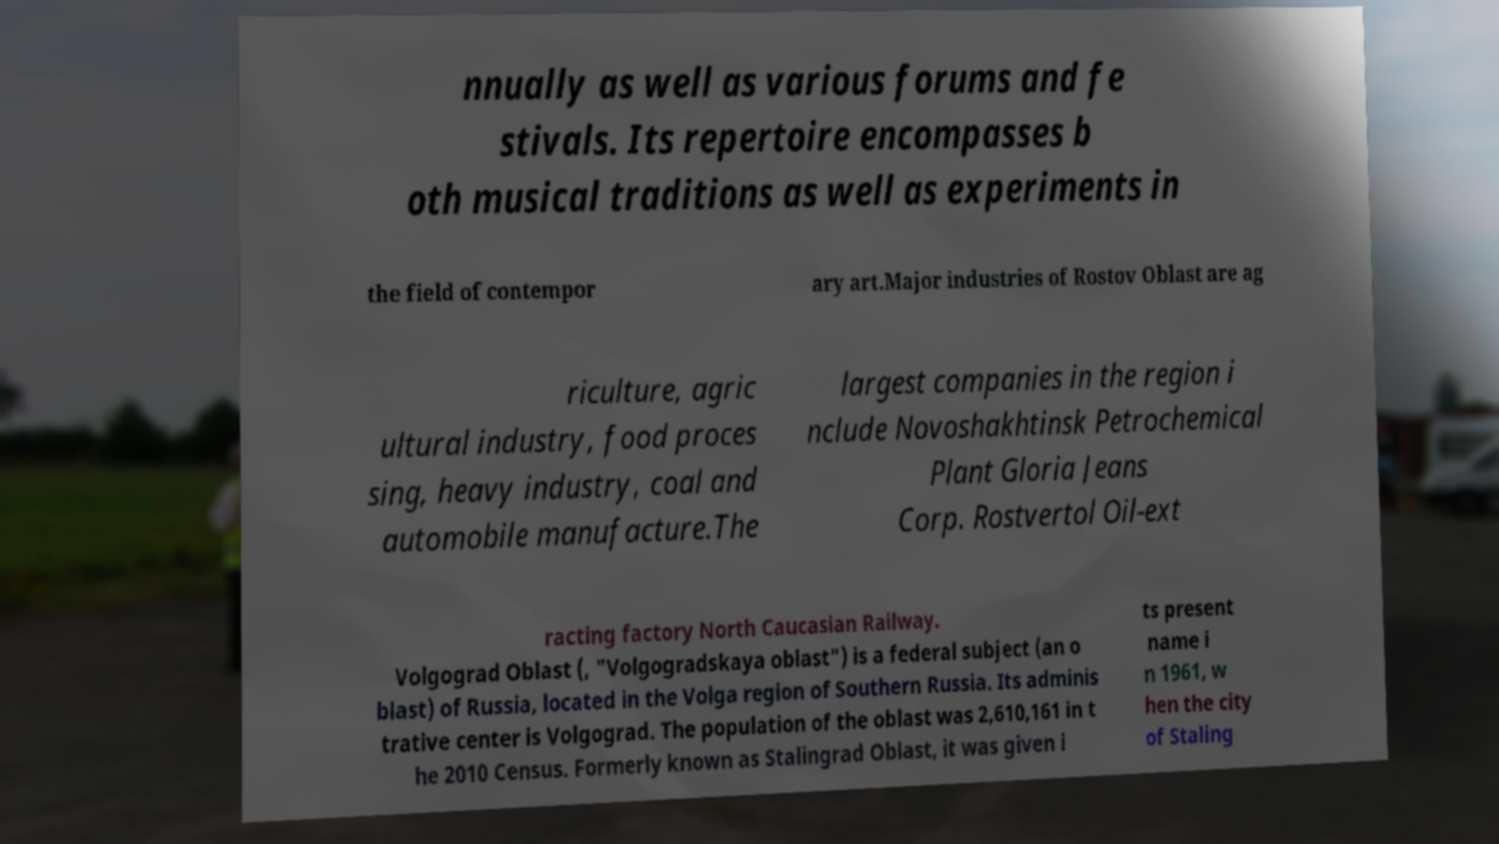Can you read and provide the text displayed in the image?This photo seems to have some interesting text. Can you extract and type it out for me? nnually as well as various forums and fe stivals. Its repertoire encompasses b oth musical traditions as well as experiments in the field of contempor ary art.Major industries of Rostov Oblast are ag riculture, agric ultural industry, food proces sing, heavy industry, coal and automobile manufacture.The largest companies in the region i nclude Novoshakhtinsk Petrochemical Plant Gloria Jeans Corp. Rostvertol Oil-ext racting factory North Caucasian Railway. Volgograd Oblast (, "Volgogradskaya oblast") is a federal subject (an o blast) of Russia, located in the Volga region of Southern Russia. Its adminis trative center is Volgograd. The population of the oblast was 2,610,161 in t he 2010 Census. Formerly known as Stalingrad Oblast, it was given i ts present name i n 1961, w hen the city of Staling 